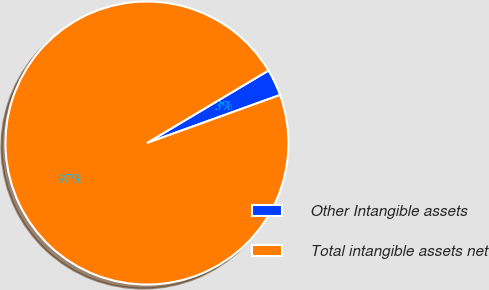<chart> <loc_0><loc_0><loc_500><loc_500><pie_chart><fcel>Other Intangible assets<fcel>Total intangible assets net<nl><fcel>3.05%<fcel>96.95%<nl></chart> 